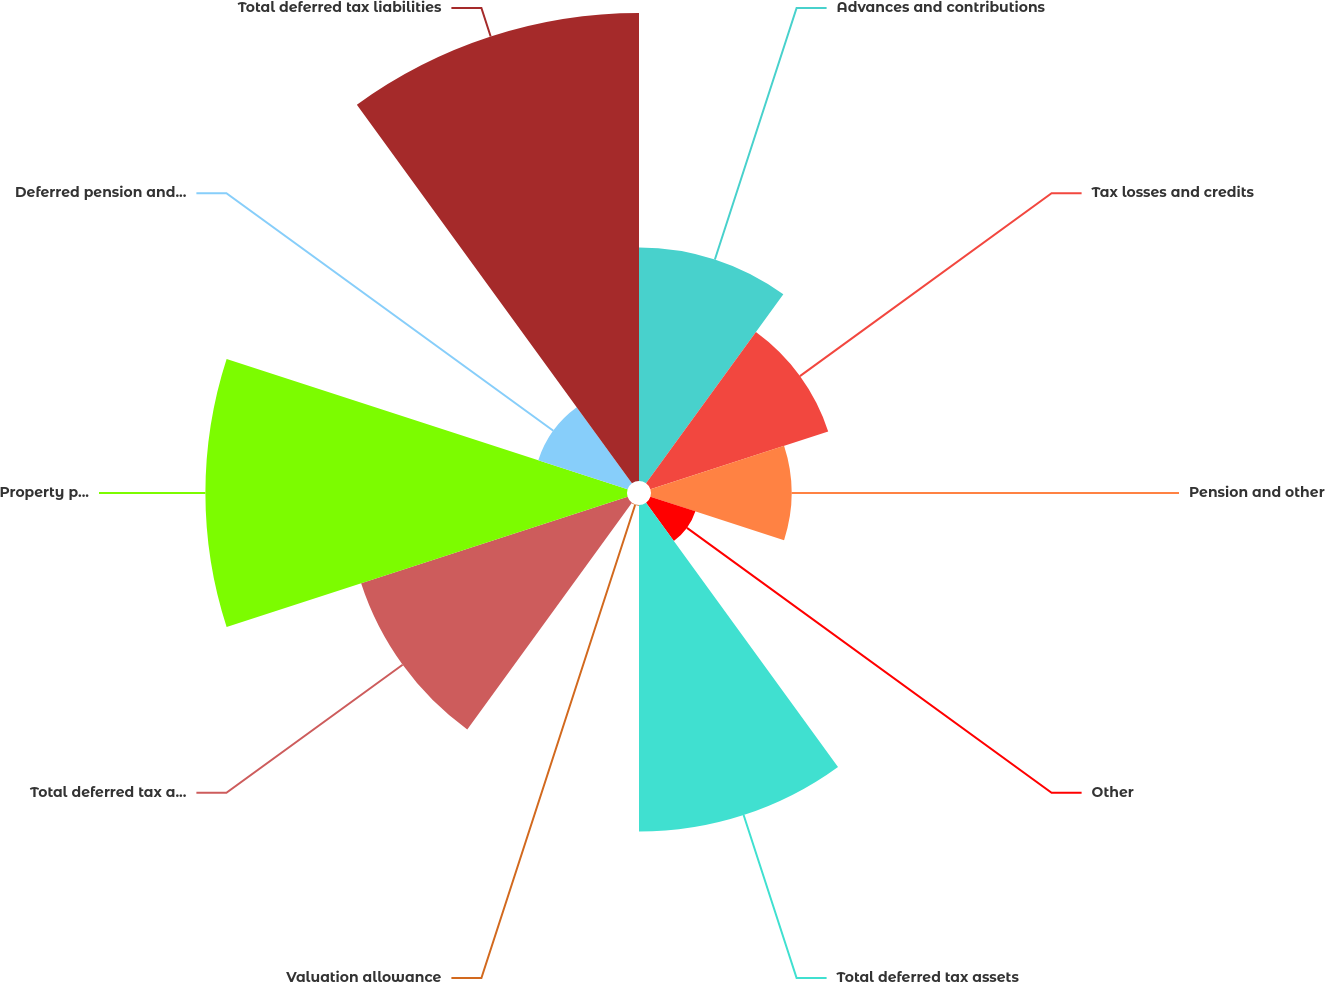Convert chart. <chart><loc_0><loc_0><loc_500><loc_500><pie_chart><fcel>Advances and contributions<fcel>Tax losses and credits<fcel>Pension and other<fcel>Other<fcel>Total deferred tax assets<fcel>Valuation allowance<fcel>Total deferred tax assets net<fcel>Property plant and equipment<fcel>Deferred pension and other<fcel>Total deferred tax liabilities<nl><fcel>10.62%<fcel>8.5%<fcel>6.39%<fcel>2.15%<fcel>14.85%<fcel>0.03%<fcel>12.74%<fcel>19.17%<fcel>4.27%<fcel>21.28%<nl></chart> 